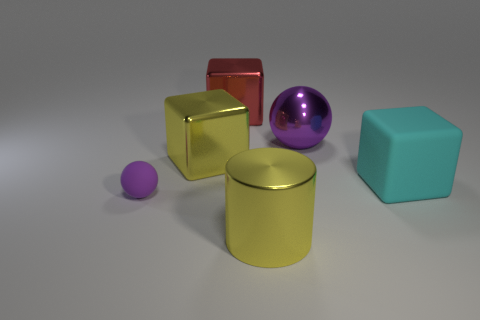There is a large object that is made of the same material as the small purple sphere; what is its color? cyan 